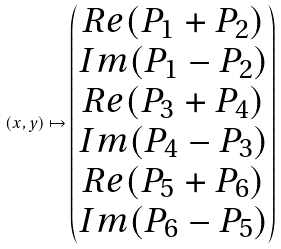Convert formula to latex. <formula><loc_0><loc_0><loc_500><loc_500>( x , y ) \mapsto \begin{pmatrix} R e ( P _ { 1 } + P _ { 2 } ) \\ I m ( P _ { 1 } - P _ { 2 } ) \\ R e ( P _ { 3 } + P _ { 4 } ) \\ I m ( P _ { 4 } - P _ { 3 } ) \\ R e ( P _ { 5 } + P _ { 6 } ) \\ I m ( P _ { 6 } - P _ { 5 } ) \end{pmatrix}</formula> 